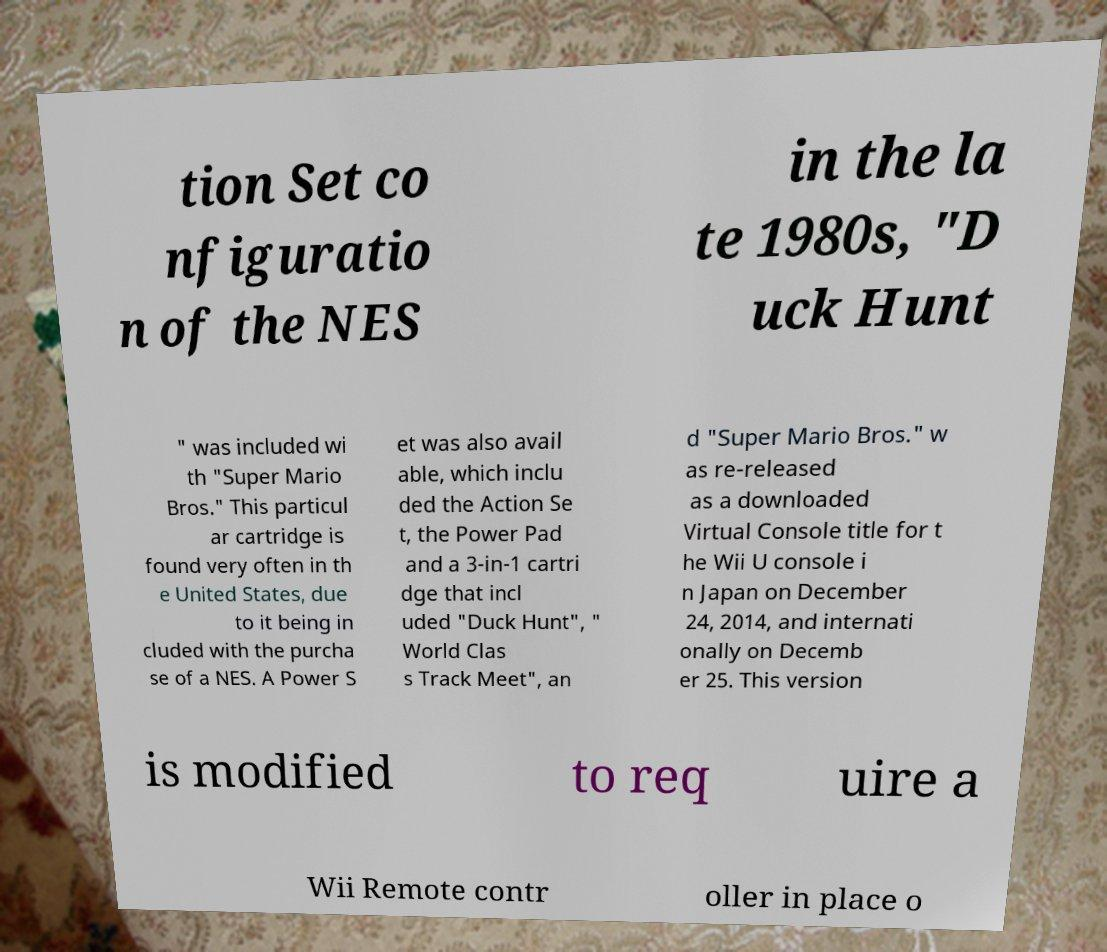There's text embedded in this image that I need extracted. Can you transcribe it verbatim? tion Set co nfiguratio n of the NES in the la te 1980s, "D uck Hunt " was included wi th "Super Mario Bros." This particul ar cartridge is found very often in th e United States, due to it being in cluded with the purcha se of a NES. A Power S et was also avail able, which inclu ded the Action Se t, the Power Pad and a 3-in-1 cartri dge that incl uded "Duck Hunt", " World Clas s Track Meet", an d "Super Mario Bros." w as re-released as a downloaded Virtual Console title for t he Wii U console i n Japan on December 24, 2014, and internati onally on Decemb er 25. This version is modified to req uire a Wii Remote contr oller in place o 